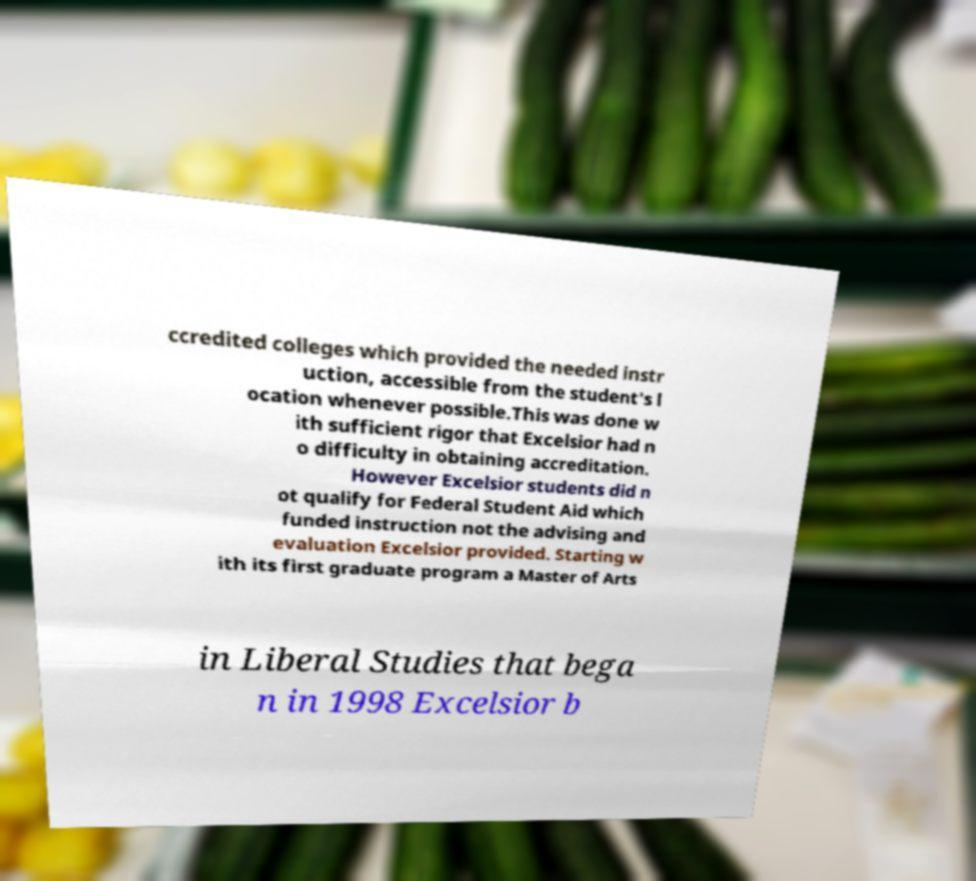Please read and relay the text visible in this image. What does it say? ccredited colleges which provided the needed instr uction, accessible from the student's l ocation whenever possible.This was done w ith sufficient rigor that Excelsior had n o difficulty in obtaining accreditation. However Excelsior students did n ot qualify for Federal Student Aid which funded instruction not the advising and evaluation Excelsior provided. Starting w ith its first graduate program a Master of Arts in Liberal Studies that bega n in 1998 Excelsior b 